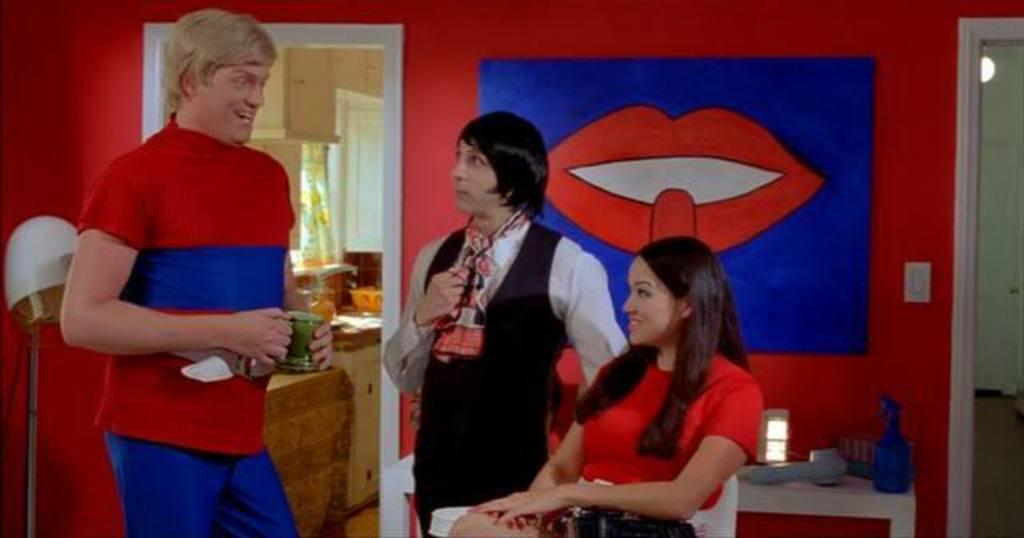What is the woman in the image doing? The woman is sitting in the image. How many people are standing in the image? There are two persons standing in the image. What is on the wall in the image? There is a photo on the wall in the image. What architectural feature is present in the image? There is a door in the image. What type of fork can be seen hanging from the door in the image? There is no fork present in the image, and the door does not have any utensils hanging from it. 